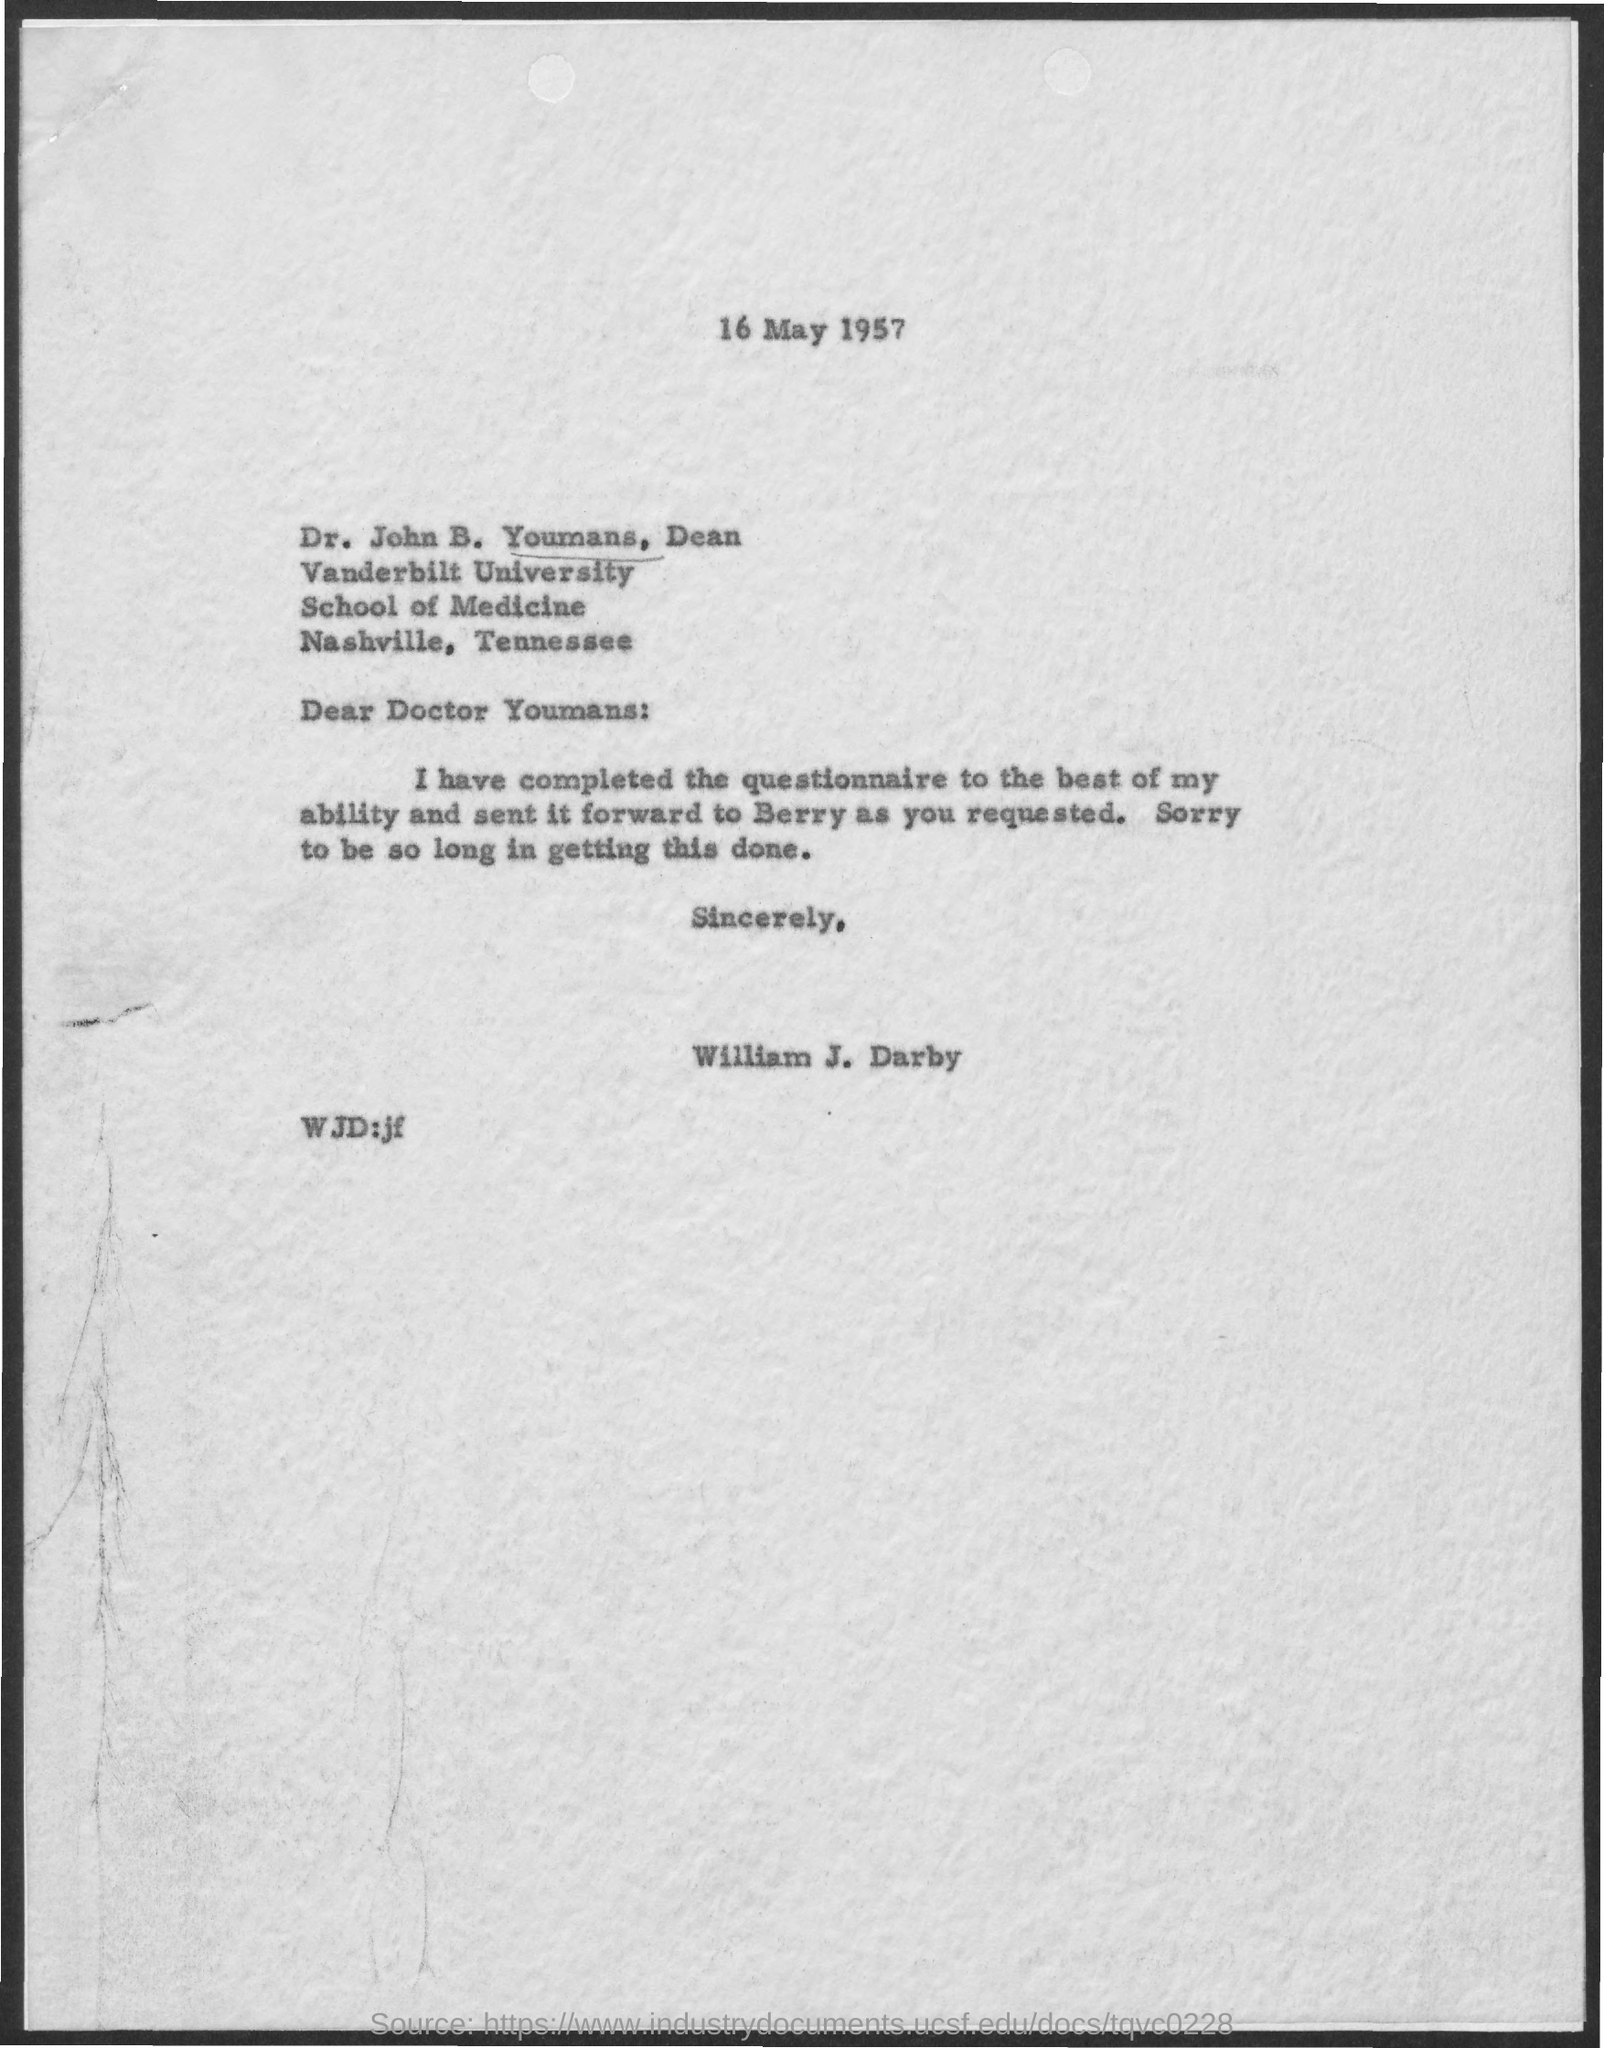Identify some key points in this picture. The sender of this message is William J. Darby. The speaker received a message that was sent forward to them by Berry. The date on the document is May 16, 1957. 